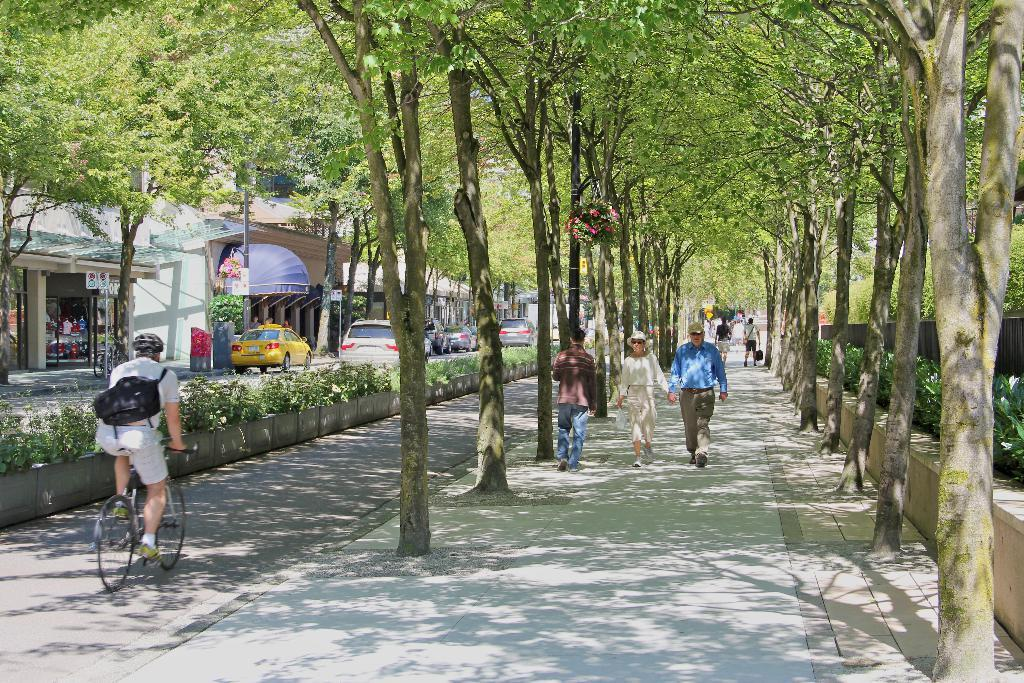What are the people in the image doing? The people in the image are walking. What is the cyclist doing in the image? One person is riding a cycle in the image. What is the cyclist wearing? The cyclist is wearing a bag. What type of structures can be seen in the image? There are houses in the image. What else can be seen moving in the image? There are vehicles in the image. What type of vegetation is present in the image? There are plants and trees in the image. Can you see the cyclist's daughter riding on the wing of the vehicle in the image? There is no daughter or wing present in the image. Are there any cacti visible in the image? There is no mention of cacti in the provided facts, and therefore we cannot determine if they are present in the image. 